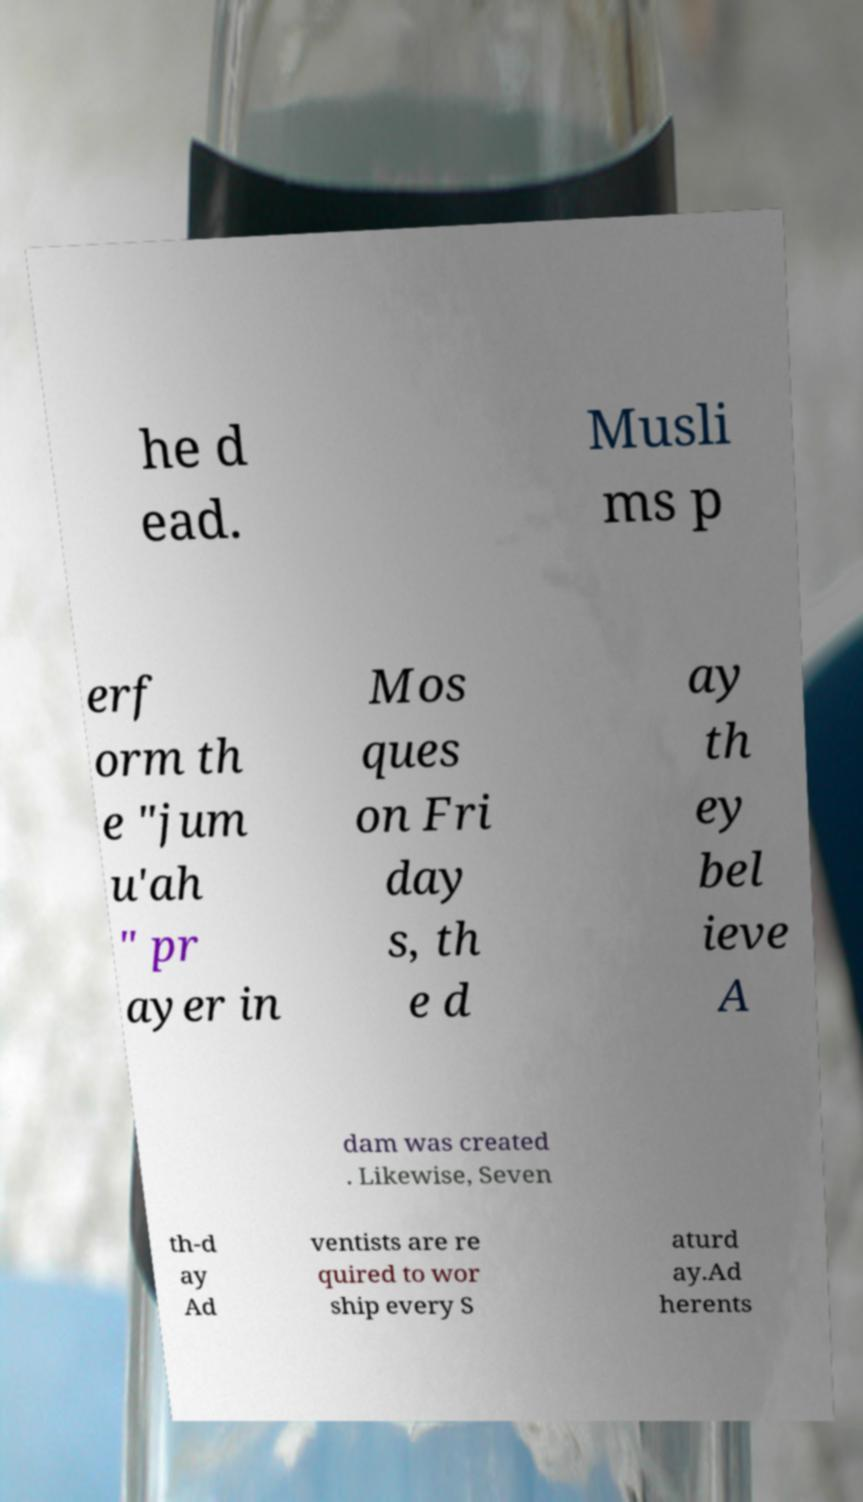Can you read and provide the text displayed in the image?This photo seems to have some interesting text. Can you extract and type it out for me? he d ead. Musli ms p erf orm th e "jum u'ah " pr ayer in Mos ques on Fri day s, th e d ay th ey bel ieve A dam was created . Likewise, Seven th-d ay Ad ventists are re quired to wor ship every S aturd ay.Ad herents 